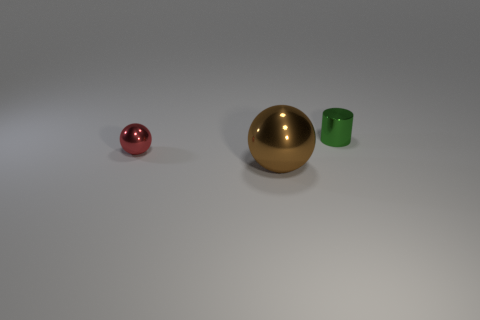Can you describe the different materials that the objects in the image are made of? Certainly! The object on the far left appears to be metallic and has a reflective, shiny red surface, suggesting it could be made of polished metal or a similar material. The large central object has a matte gold color, indicative of a brass or golden surface, while the object on the far right has a matte green finish that could be either painted metal or a ceramic material. 